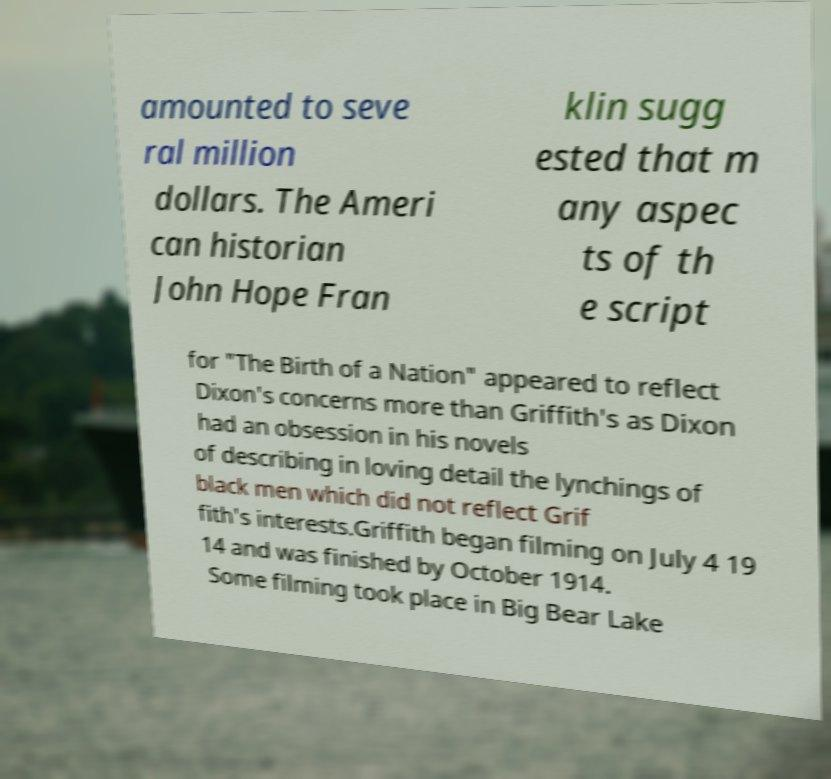Please read and relay the text visible in this image. What does it say? amounted to seve ral million dollars. The Ameri can historian John Hope Fran klin sugg ested that m any aspec ts of th e script for "The Birth of a Nation" appeared to reflect Dixon's concerns more than Griffith's as Dixon had an obsession in his novels of describing in loving detail the lynchings of black men which did not reflect Grif fith's interests.Griffith began filming on July 4 19 14 and was finished by October 1914. Some filming took place in Big Bear Lake 